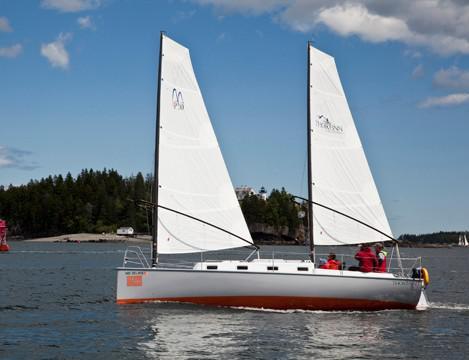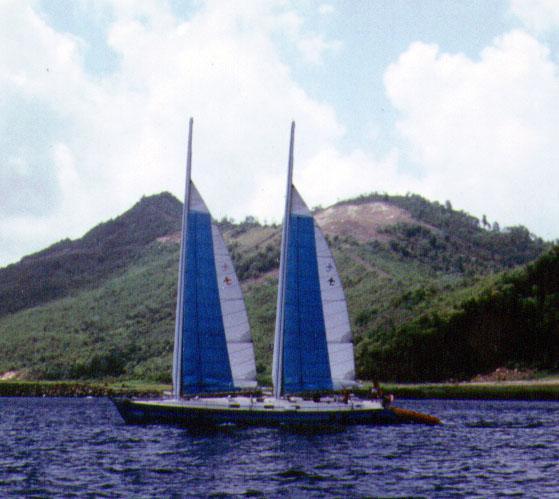The first image is the image on the left, the second image is the image on the right. Given the left and right images, does the statement "All the boats are heading in the same direction." hold true? Answer yes or no. Yes. The first image is the image on the left, the second image is the image on the right. Examine the images to the left and right. Is the description "One image features a boat with a blue-looking body, and the other image shows a boat with the upright masts of two triangular white sails on the left." accurate? Answer yes or no. Yes. 